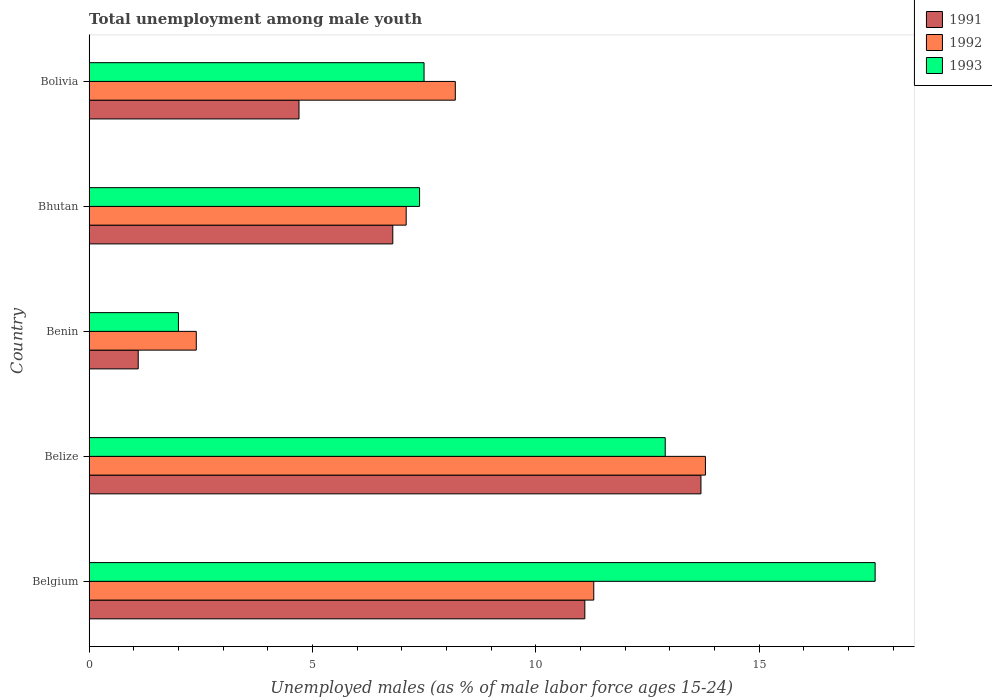How many different coloured bars are there?
Offer a terse response. 3. Are the number of bars per tick equal to the number of legend labels?
Keep it short and to the point. Yes. How many bars are there on the 1st tick from the top?
Offer a terse response. 3. How many bars are there on the 1st tick from the bottom?
Offer a terse response. 3. What is the label of the 4th group of bars from the top?
Make the answer very short. Belize. In how many cases, is the number of bars for a given country not equal to the number of legend labels?
Your response must be concise. 0. What is the percentage of unemployed males in in 1993 in Bolivia?
Provide a short and direct response. 7.5. Across all countries, what is the maximum percentage of unemployed males in in 1993?
Provide a succinct answer. 17.6. Across all countries, what is the minimum percentage of unemployed males in in 1992?
Ensure brevity in your answer.  2.4. In which country was the percentage of unemployed males in in 1991 maximum?
Offer a terse response. Belize. In which country was the percentage of unemployed males in in 1993 minimum?
Keep it short and to the point. Benin. What is the total percentage of unemployed males in in 1993 in the graph?
Your answer should be very brief. 47.4. What is the difference between the percentage of unemployed males in in 1991 in Belgium and that in Belize?
Your answer should be compact. -2.6. What is the difference between the percentage of unemployed males in in 1993 in Bolivia and the percentage of unemployed males in in 1992 in Bhutan?
Make the answer very short. 0.4. What is the average percentage of unemployed males in in 1993 per country?
Offer a very short reply. 9.48. What is the difference between the percentage of unemployed males in in 1991 and percentage of unemployed males in in 1992 in Belgium?
Provide a short and direct response. -0.2. What is the ratio of the percentage of unemployed males in in 1993 in Benin to that in Bhutan?
Keep it short and to the point. 0.27. Is the difference between the percentage of unemployed males in in 1991 in Belgium and Bhutan greater than the difference between the percentage of unemployed males in in 1992 in Belgium and Bhutan?
Your answer should be compact. Yes. What is the difference between the highest and the second highest percentage of unemployed males in in 1992?
Make the answer very short. 2.5. What is the difference between the highest and the lowest percentage of unemployed males in in 1991?
Keep it short and to the point. 12.6. Is the sum of the percentage of unemployed males in in 1993 in Belize and Bhutan greater than the maximum percentage of unemployed males in in 1991 across all countries?
Offer a very short reply. Yes. What does the 2nd bar from the top in Belgium represents?
Offer a terse response. 1992. What does the 1st bar from the bottom in Bolivia represents?
Give a very brief answer. 1991. What is the difference between two consecutive major ticks on the X-axis?
Make the answer very short. 5. Are the values on the major ticks of X-axis written in scientific E-notation?
Give a very brief answer. No. Where does the legend appear in the graph?
Keep it short and to the point. Top right. How many legend labels are there?
Your answer should be very brief. 3. How are the legend labels stacked?
Your response must be concise. Vertical. What is the title of the graph?
Keep it short and to the point. Total unemployment among male youth. Does "1982" appear as one of the legend labels in the graph?
Give a very brief answer. No. What is the label or title of the X-axis?
Give a very brief answer. Unemployed males (as % of male labor force ages 15-24). What is the Unemployed males (as % of male labor force ages 15-24) in 1991 in Belgium?
Your response must be concise. 11.1. What is the Unemployed males (as % of male labor force ages 15-24) in 1992 in Belgium?
Offer a very short reply. 11.3. What is the Unemployed males (as % of male labor force ages 15-24) of 1993 in Belgium?
Offer a terse response. 17.6. What is the Unemployed males (as % of male labor force ages 15-24) in 1991 in Belize?
Provide a succinct answer. 13.7. What is the Unemployed males (as % of male labor force ages 15-24) in 1992 in Belize?
Provide a succinct answer. 13.8. What is the Unemployed males (as % of male labor force ages 15-24) of 1993 in Belize?
Provide a short and direct response. 12.9. What is the Unemployed males (as % of male labor force ages 15-24) in 1991 in Benin?
Your answer should be compact. 1.1. What is the Unemployed males (as % of male labor force ages 15-24) in 1992 in Benin?
Make the answer very short. 2.4. What is the Unemployed males (as % of male labor force ages 15-24) in 1993 in Benin?
Give a very brief answer. 2. What is the Unemployed males (as % of male labor force ages 15-24) of 1991 in Bhutan?
Keep it short and to the point. 6.8. What is the Unemployed males (as % of male labor force ages 15-24) of 1992 in Bhutan?
Your answer should be very brief. 7.1. What is the Unemployed males (as % of male labor force ages 15-24) in 1993 in Bhutan?
Give a very brief answer. 7.4. What is the Unemployed males (as % of male labor force ages 15-24) in 1991 in Bolivia?
Ensure brevity in your answer.  4.7. What is the Unemployed males (as % of male labor force ages 15-24) in 1992 in Bolivia?
Make the answer very short. 8.2. Across all countries, what is the maximum Unemployed males (as % of male labor force ages 15-24) in 1991?
Give a very brief answer. 13.7. Across all countries, what is the maximum Unemployed males (as % of male labor force ages 15-24) of 1992?
Offer a very short reply. 13.8. Across all countries, what is the maximum Unemployed males (as % of male labor force ages 15-24) of 1993?
Provide a short and direct response. 17.6. Across all countries, what is the minimum Unemployed males (as % of male labor force ages 15-24) of 1991?
Provide a succinct answer. 1.1. Across all countries, what is the minimum Unemployed males (as % of male labor force ages 15-24) in 1992?
Your answer should be compact. 2.4. What is the total Unemployed males (as % of male labor force ages 15-24) in 1991 in the graph?
Keep it short and to the point. 37.4. What is the total Unemployed males (as % of male labor force ages 15-24) of 1992 in the graph?
Make the answer very short. 42.8. What is the total Unemployed males (as % of male labor force ages 15-24) of 1993 in the graph?
Offer a terse response. 47.4. What is the difference between the Unemployed males (as % of male labor force ages 15-24) in 1991 in Belgium and that in Belize?
Keep it short and to the point. -2.6. What is the difference between the Unemployed males (as % of male labor force ages 15-24) of 1993 in Belgium and that in Belize?
Provide a succinct answer. 4.7. What is the difference between the Unemployed males (as % of male labor force ages 15-24) in 1992 in Belgium and that in Bhutan?
Provide a short and direct response. 4.2. What is the difference between the Unemployed males (as % of male labor force ages 15-24) of 1991 in Belgium and that in Bolivia?
Offer a terse response. 6.4. What is the difference between the Unemployed males (as % of male labor force ages 15-24) of 1992 in Belgium and that in Bolivia?
Make the answer very short. 3.1. What is the difference between the Unemployed males (as % of male labor force ages 15-24) in 1993 in Belgium and that in Bolivia?
Your answer should be very brief. 10.1. What is the difference between the Unemployed males (as % of male labor force ages 15-24) in 1991 in Belize and that in Benin?
Your response must be concise. 12.6. What is the difference between the Unemployed males (as % of male labor force ages 15-24) of 1993 in Belize and that in Bhutan?
Your answer should be very brief. 5.5. What is the difference between the Unemployed males (as % of male labor force ages 15-24) in 1991 in Benin and that in Bhutan?
Offer a terse response. -5.7. What is the difference between the Unemployed males (as % of male labor force ages 15-24) in 1992 in Benin and that in Bhutan?
Keep it short and to the point. -4.7. What is the difference between the Unemployed males (as % of male labor force ages 15-24) in 1993 in Benin and that in Bolivia?
Provide a short and direct response. -5.5. What is the difference between the Unemployed males (as % of male labor force ages 15-24) of 1992 in Bhutan and that in Bolivia?
Ensure brevity in your answer.  -1.1. What is the difference between the Unemployed males (as % of male labor force ages 15-24) in 1991 in Belgium and the Unemployed males (as % of male labor force ages 15-24) in 1992 in Belize?
Provide a short and direct response. -2.7. What is the difference between the Unemployed males (as % of male labor force ages 15-24) of 1991 in Belgium and the Unemployed males (as % of male labor force ages 15-24) of 1993 in Belize?
Provide a succinct answer. -1.8. What is the difference between the Unemployed males (as % of male labor force ages 15-24) in 1991 in Belgium and the Unemployed males (as % of male labor force ages 15-24) in 1992 in Benin?
Provide a short and direct response. 8.7. What is the difference between the Unemployed males (as % of male labor force ages 15-24) in 1991 in Belgium and the Unemployed males (as % of male labor force ages 15-24) in 1993 in Bhutan?
Ensure brevity in your answer.  3.7. What is the difference between the Unemployed males (as % of male labor force ages 15-24) in 1991 in Belgium and the Unemployed males (as % of male labor force ages 15-24) in 1993 in Bolivia?
Ensure brevity in your answer.  3.6. What is the difference between the Unemployed males (as % of male labor force ages 15-24) in 1992 in Belgium and the Unemployed males (as % of male labor force ages 15-24) in 1993 in Bolivia?
Offer a very short reply. 3.8. What is the difference between the Unemployed males (as % of male labor force ages 15-24) in 1991 in Belize and the Unemployed males (as % of male labor force ages 15-24) in 1993 in Benin?
Your answer should be compact. 11.7. What is the difference between the Unemployed males (as % of male labor force ages 15-24) of 1991 in Belize and the Unemployed males (as % of male labor force ages 15-24) of 1992 in Bolivia?
Your answer should be very brief. 5.5. What is the difference between the Unemployed males (as % of male labor force ages 15-24) in 1991 in Belize and the Unemployed males (as % of male labor force ages 15-24) in 1993 in Bolivia?
Keep it short and to the point. 6.2. What is the difference between the Unemployed males (as % of male labor force ages 15-24) of 1991 in Benin and the Unemployed males (as % of male labor force ages 15-24) of 1992 in Bhutan?
Offer a very short reply. -6. What is the difference between the Unemployed males (as % of male labor force ages 15-24) in 1992 in Benin and the Unemployed males (as % of male labor force ages 15-24) in 1993 in Bhutan?
Make the answer very short. -5. What is the difference between the Unemployed males (as % of male labor force ages 15-24) of 1991 in Benin and the Unemployed males (as % of male labor force ages 15-24) of 1992 in Bolivia?
Your answer should be compact. -7.1. What is the difference between the Unemployed males (as % of male labor force ages 15-24) in 1991 in Bhutan and the Unemployed males (as % of male labor force ages 15-24) in 1993 in Bolivia?
Ensure brevity in your answer.  -0.7. What is the difference between the Unemployed males (as % of male labor force ages 15-24) of 1992 in Bhutan and the Unemployed males (as % of male labor force ages 15-24) of 1993 in Bolivia?
Your answer should be very brief. -0.4. What is the average Unemployed males (as % of male labor force ages 15-24) in 1991 per country?
Offer a terse response. 7.48. What is the average Unemployed males (as % of male labor force ages 15-24) in 1992 per country?
Provide a short and direct response. 8.56. What is the average Unemployed males (as % of male labor force ages 15-24) of 1993 per country?
Your answer should be very brief. 9.48. What is the difference between the Unemployed males (as % of male labor force ages 15-24) in 1991 and Unemployed males (as % of male labor force ages 15-24) in 1993 in Belgium?
Provide a succinct answer. -6.5. What is the difference between the Unemployed males (as % of male labor force ages 15-24) in 1992 and Unemployed males (as % of male labor force ages 15-24) in 1993 in Belgium?
Keep it short and to the point. -6.3. What is the difference between the Unemployed males (as % of male labor force ages 15-24) in 1992 and Unemployed males (as % of male labor force ages 15-24) in 1993 in Belize?
Your answer should be very brief. 0.9. What is the difference between the Unemployed males (as % of male labor force ages 15-24) of 1991 and Unemployed males (as % of male labor force ages 15-24) of 1992 in Benin?
Your response must be concise. -1.3. What is the difference between the Unemployed males (as % of male labor force ages 15-24) of 1992 and Unemployed males (as % of male labor force ages 15-24) of 1993 in Benin?
Provide a succinct answer. 0.4. What is the difference between the Unemployed males (as % of male labor force ages 15-24) of 1991 and Unemployed males (as % of male labor force ages 15-24) of 1992 in Bhutan?
Offer a terse response. -0.3. What is the difference between the Unemployed males (as % of male labor force ages 15-24) in 1991 and Unemployed males (as % of male labor force ages 15-24) in 1993 in Bhutan?
Ensure brevity in your answer.  -0.6. What is the difference between the Unemployed males (as % of male labor force ages 15-24) of 1992 and Unemployed males (as % of male labor force ages 15-24) of 1993 in Bhutan?
Make the answer very short. -0.3. What is the difference between the Unemployed males (as % of male labor force ages 15-24) of 1991 and Unemployed males (as % of male labor force ages 15-24) of 1992 in Bolivia?
Give a very brief answer. -3.5. What is the difference between the Unemployed males (as % of male labor force ages 15-24) of 1991 and Unemployed males (as % of male labor force ages 15-24) of 1993 in Bolivia?
Give a very brief answer. -2.8. What is the ratio of the Unemployed males (as % of male labor force ages 15-24) in 1991 in Belgium to that in Belize?
Provide a short and direct response. 0.81. What is the ratio of the Unemployed males (as % of male labor force ages 15-24) of 1992 in Belgium to that in Belize?
Your answer should be very brief. 0.82. What is the ratio of the Unemployed males (as % of male labor force ages 15-24) in 1993 in Belgium to that in Belize?
Your answer should be very brief. 1.36. What is the ratio of the Unemployed males (as % of male labor force ages 15-24) of 1991 in Belgium to that in Benin?
Your answer should be very brief. 10.09. What is the ratio of the Unemployed males (as % of male labor force ages 15-24) in 1992 in Belgium to that in Benin?
Offer a very short reply. 4.71. What is the ratio of the Unemployed males (as % of male labor force ages 15-24) of 1993 in Belgium to that in Benin?
Your answer should be compact. 8.8. What is the ratio of the Unemployed males (as % of male labor force ages 15-24) in 1991 in Belgium to that in Bhutan?
Offer a very short reply. 1.63. What is the ratio of the Unemployed males (as % of male labor force ages 15-24) in 1992 in Belgium to that in Bhutan?
Provide a short and direct response. 1.59. What is the ratio of the Unemployed males (as % of male labor force ages 15-24) in 1993 in Belgium to that in Bhutan?
Your response must be concise. 2.38. What is the ratio of the Unemployed males (as % of male labor force ages 15-24) in 1991 in Belgium to that in Bolivia?
Your answer should be compact. 2.36. What is the ratio of the Unemployed males (as % of male labor force ages 15-24) of 1992 in Belgium to that in Bolivia?
Provide a succinct answer. 1.38. What is the ratio of the Unemployed males (as % of male labor force ages 15-24) of 1993 in Belgium to that in Bolivia?
Ensure brevity in your answer.  2.35. What is the ratio of the Unemployed males (as % of male labor force ages 15-24) of 1991 in Belize to that in Benin?
Your answer should be compact. 12.45. What is the ratio of the Unemployed males (as % of male labor force ages 15-24) of 1992 in Belize to that in Benin?
Make the answer very short. 5.75. What is the ratio of the Unemployed males (as % of male labor force ages 15-24) of 1993 in Belize to that in Benin?
Give a very brief answer. 6.45. What is the ratio of the Unemployed males (as % of male labor force ages 15-24) in 1991 in Belize to that in Bhutan?
Provide a short and direct response. 2.01. What is the ratio of the Unemployed males (as % of male labor force ages 15-24) of 1992 in Belize to that in Bhutan?
Give a very brief answer. 1.94. What is the ratio of the Unemployed males (as % of male labor force ages 15-24) of 1993 in Belize to that in Bhutan?
Give a very brief answer. 1.74. What is the ratio of the Unemployed males (as % of male labor force ages 15-24) in 1991 in Belize to that in Bolivia?
Make the answer very short. 2.91. What is the ratio of the Unemployed males (as % of male labor force ages 15-24) of 1992 in Belize to that in Bolivia?
Ensure brevity in your answer.  1.68. What is the ratio of the Unemployed males (as % of male labor force ages 15-24) in 1993 in Belize to that in Bolivia?
Keep it short and to the point. 1.72. What is the ratio of the Unemployed males (as % of male labor force ages 15-24) in 1991 in Benin to that in Bhutan?
Your answer should be compact. 0.16. What is the ratio of the Unemployed males (as % of male labor force ages 15-24) of 1992 in Benin to that in Bhutan?
Give a very brief answer. 0.34. What is the ratio of the Unemployed males (as % of male labor force ages 15-24) of 1993 in Benin to that in Bhutan?
Make the answer very short. 0.27. What is the ratio of the Unemployed males (as % of male labor force ages 15-24) in 1991 in Benin to that in Bolivia?
Provide a short and direct response. 0.23. What is the ratio of the Unemployed males (as % of male labor force ages 15-24) in 1992 in Benin to that in Bolivia?
Ensure brevity in your answer.  0.29. What is the ratio of the Unemployed males (as % of male labor force ages 15-24) in 1993 in Benin to that in Bolivia?
Offer a very short reply. 0.27. What is the ratio of the Unemployed males (as % of male labor force ages 15-24) of 1991 in Bhutan to that in Bolivia?
Your answer should be very brief. 1.45. What is the ratio of the Unemployed males (as % of male labor force ages 15-24) of 1992 in Bhutan to that in Bolivia?
Give a very brief answer. 0.87. What is the ratio of the Unemployed males (as % of male labor force ages 15-24) of 1993 in Bhutan to that in Bolivia?
Make the answer very short. 0.99. What is the difference between the highest and the second highest Unemployed males (as % of male labor force ages 15-24) of 1991?
Keep it short and to the point. 2.6. What is the difference between the highest and the second highest Unemployed males (as % of male labor force ages 15-24) of 1992?
Ensure brevity in your answer.  2.5. 